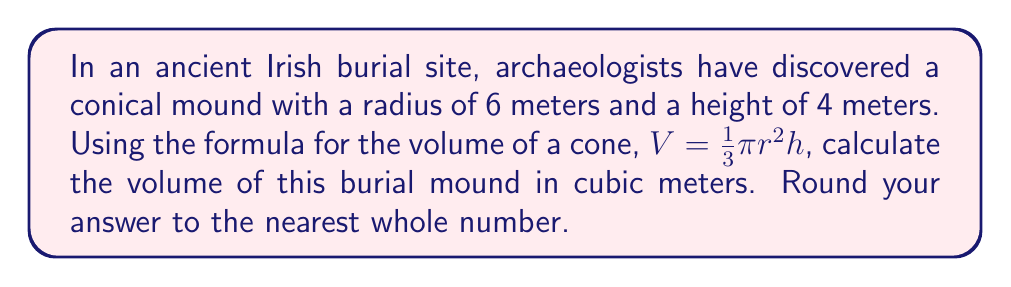What is the answer to this math problem? Let's approach this step-by-step:

1) We're given the formula for the volume of a cone:
   $V = \frac{1}{3}\pi r^2 h$

2) We know:
   - Radius (r) = 6 meters
   - Height (h) = 4 meters

3) Let's substitute these values into the formula:
   $V = \frac{1}{3}\pi (6^2) (4)$

4) First, let's calculate $6^2$:
   $V = \frac{1}{3}\pi (36) (4)$

5) Now multiply 36 and 4:
   $V = \frac{1}{3}\pi (144)$

6) Multiply by $\frac{1}{3}$:
   $V = 48\pi$

7) Use 3.14159 as an approximation for $\pi$:
   $V \approx 48 (3.14159)$
   $V \approx 150.79632$

8) Rounding to the nearest whole number:
   $V \approx 151$

Therefore, the volume of the burial mound is approximately 151 cubic meters.
Answer: 151 cubic meters 